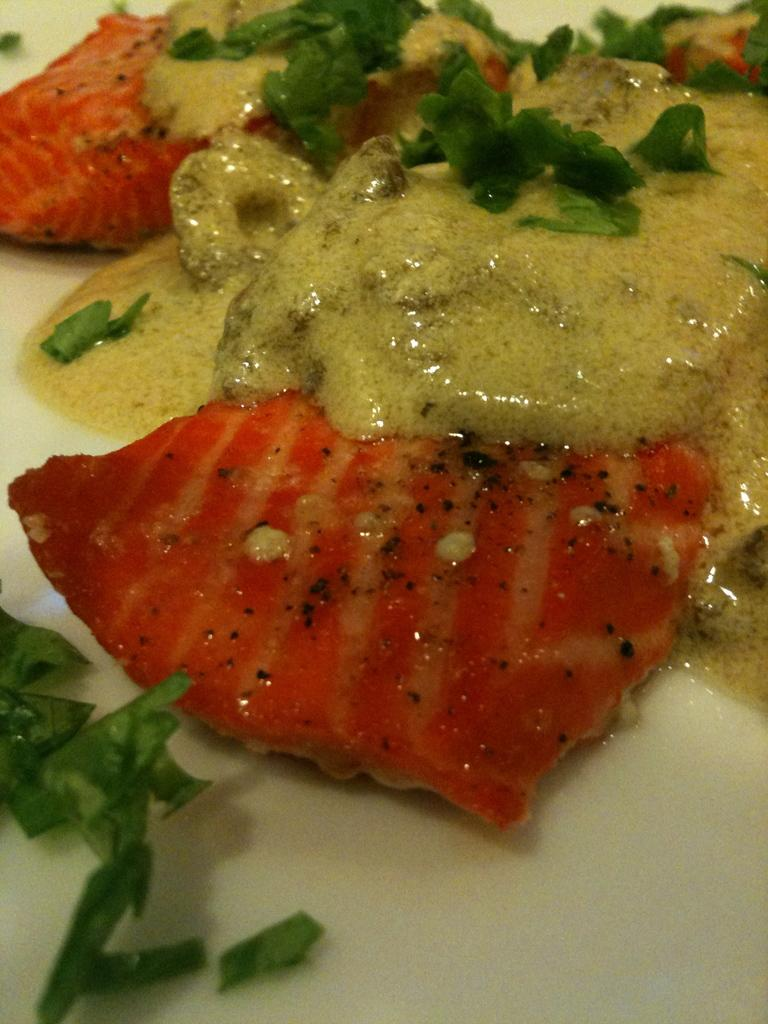What is the main subject of the image? There is an edible in the image. Can you describe the surface on which the edible is placed? The edible is placed on a white surface. What type of arm is visible in the image? There is no arm present in the image; it only features an edible placed on a white surface. 